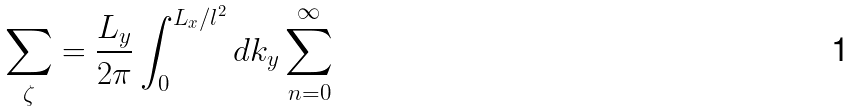Convert formula to latex. <formula><loc_0><loc_0><loc_500><loc_500>\sum _ { \zeta } = \frac { L _ { y } } { 2 \pi } \int _ { 0 } ^ { L _ { x } / l ^ { 2 } } d k _ { y } \sum _ { n = 0 } ^ { \infty }</formula> 